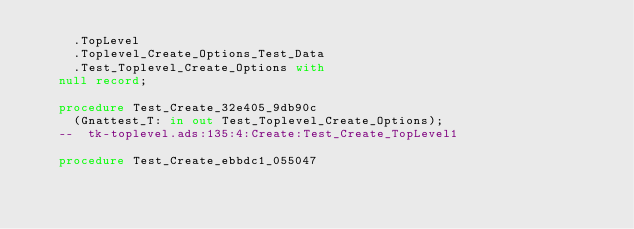Convert code to text. <code><loc_0><loc_0><loc_500><loc_500><_Ada_>     .TopLevel
     .Toplevel_Create_Options_Test_Data
     .Test_Toplevel_Create_Options with
   null record;

   procedure Test_Create_32e405_9db90c
     (Gnattest_T: in out Test_Toplevel_Create_Options);
   --  tk-toplevel.ads:135:4:Create:Test_Create_TopLevel1

   procedure Test_Create_ebbdc1_055047</code> 